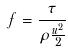<formula> <loc_0><loc_0><loc_500><loc_500>f = \frac { \tau } { \rho \frac { u ^ { 2 } } { 2 } }</formula> 